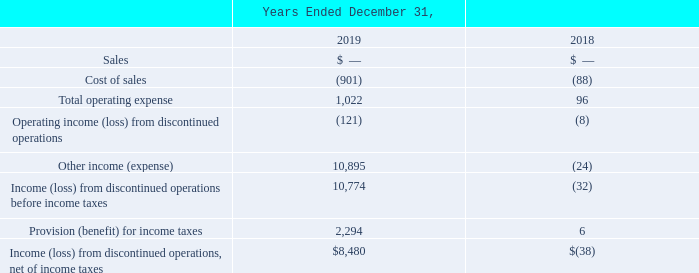Discontinued Operations
In December 2015, we completed the wind down of engineering, manufacturing and sales of our solar inverter product line (the "inverter business"). Accordingly, the results of our inverter business have been reflected as “Income (loss) from discontinued operations, net of income taxes” on our Consolidated Statements of Operations for all periods presented herein.
The effect of our sales of extended inverter warranties to our customers continues to be reflected in deferred revenue in our Consolidated Balance Sheets. Deferred revenue for extended inverter warranties and the associated costs of warranty service will be reflected in Sales and Cost of goods sold, respectively, from continuing operations in future periods in our Consolidated Statement of Operations, as the deferred revenue, is earned and the associated services are rendered. Extended warranties related to the inverter product line are no longer offered.
ADVANCED ENERGY INDUSTRIES, INC. NOTES TO CONSOLIDATED FINANCIAL STATEMENTS – (continued) (in thousands, except per share amounts)
The significant items included in "Income (loss) from discontinued operations, net of income taxes" are as follows:
What was the cost of sales in 2019?
Answer scale should be: thousand. (901). What was the Total operating expense in 2018?
Answer scale should be: thousand. 96. What was the Provision (benefit) for income taxes in 2018?
Answer scale should be: thousand. 6. What was the change in Provision (benefit) for income taxes between 2018 and 2019?
Answer scale should be: thousand. 2,294-6
Answer: 2288. What was the percentage change in Cost of sales between 2018 and 2019?
Answer scale should be: percent. (-901-(-88))/-88
Answer: 923.86. What was the percentage change in Income (loss) from discontinued operations, net of income taxes between 2018 and 2019?
Answer scale should be: percent. ($8,480-(-$38))/-$38
Answer: -22415.79. 